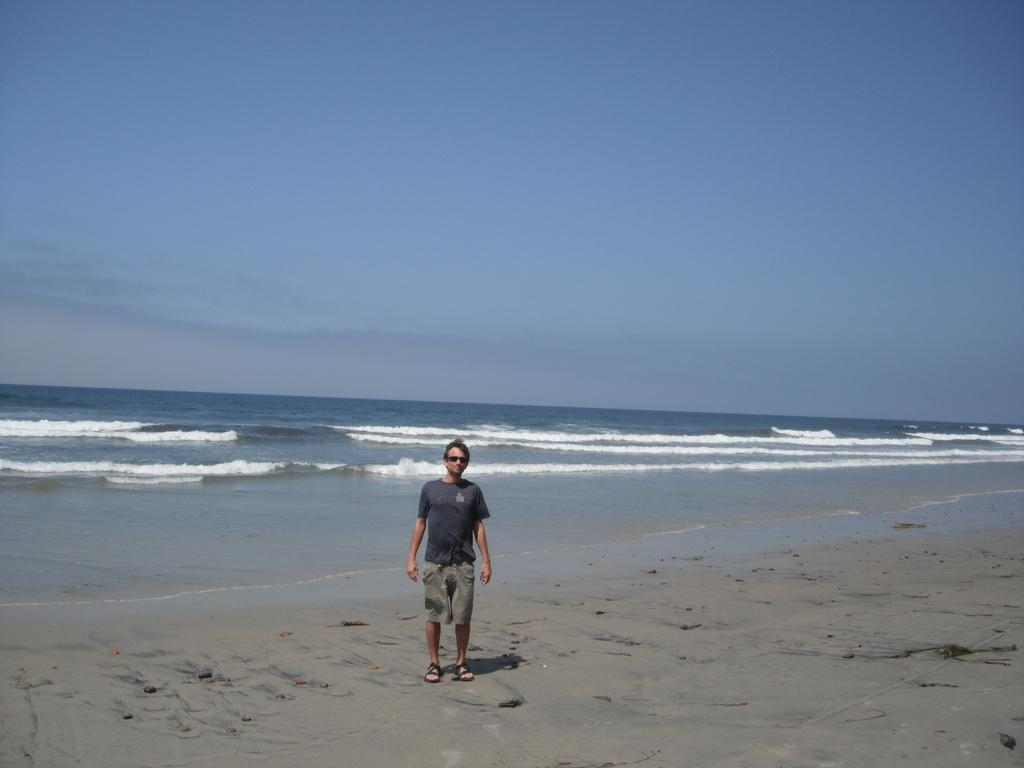What is the main setting of the picture? There is a beach in the picture. Can you describe any people or objects in the image? There is a person standing on the beach. What is visible at the top of the image? The sky is visible at the top of the image. What type of cough can be heard from the person on the beach in the image? There is no indication of any sound, including a cough, in the image. 